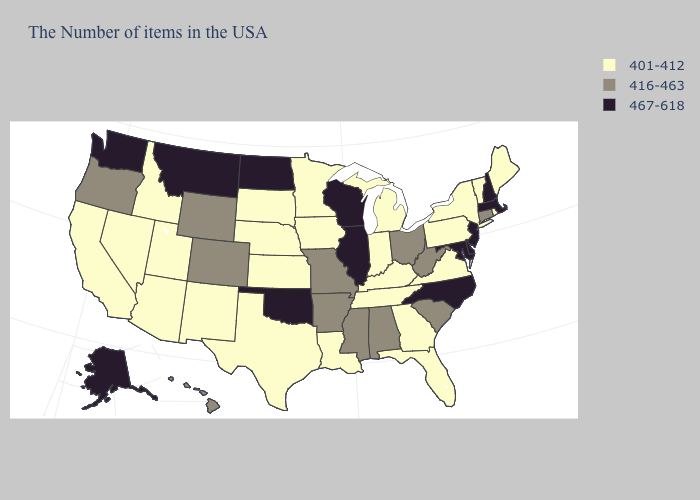Does Kentucky have the lowest value in the South?
Concise answer only. Yes. What is the highest value in the USA?
Short answer required. 467-618. Name the states that have a value in the range 467-618?
Keep it brief. Massachusetts, New Hampshire, New Jersey, Delaware, Maryland, North Carolina, Wisconsin, Illinois, Oklahoma, North Dakota, Montana, Washington, Alaska. What is the value of New Hampshire?
Give a very brief answer. 467-618. Name the states that have a value in the range 416-463?
Quick response, please. Connecticut, South Carolina, West Virginia, Ohio, Alabama, Mississippi, Missouri, Arkansas, Wyoming, Colorado, Oregon, Hawaii. What is the highest value in the USA?
Answer briefly. 467-618. Name the states that have a value in the range 416-463?
Be succinct. Connecticut, South Carolina, West Virginia, Ohio, Alabama, Mississippi, Missouri, Arkansas, Wyoming, Colorado, Oregon, Hawaii. Does Alabama have a lower value than Delaware?
Write a very short answer. Yes. Which states have the highest value in the USA?
Short answer required. Massachusetts, New Hampshire, New Jersey, Delaware, Maryland, North Carolina, Wisconsin, Illinois, Oklahoma, North Dakota, Montana, Washington, Alaska. What is the value of Utah?
Quick response, please. 401-412. Does Vermont have a higher value than Ohio?
Give a very brief answer. No. Does Arkansas have a lower value than Illinois?
Be succinct. Yes. Name the states that have a value in the range 416-463?
Write a very short answer. Connecticut, South Carolina, West Virginia, Ohio, Alabama, Mississippi, Missouri, Arkansas, Wyoming, Colorado, Oregon, Hawaii. Among the states that border Oklahoma , does Arkansas have the highest value?
Give a very brief answer. Yes. Among the states that border Nevada , does Arizona have the highest value?
Concise answer only. No. 